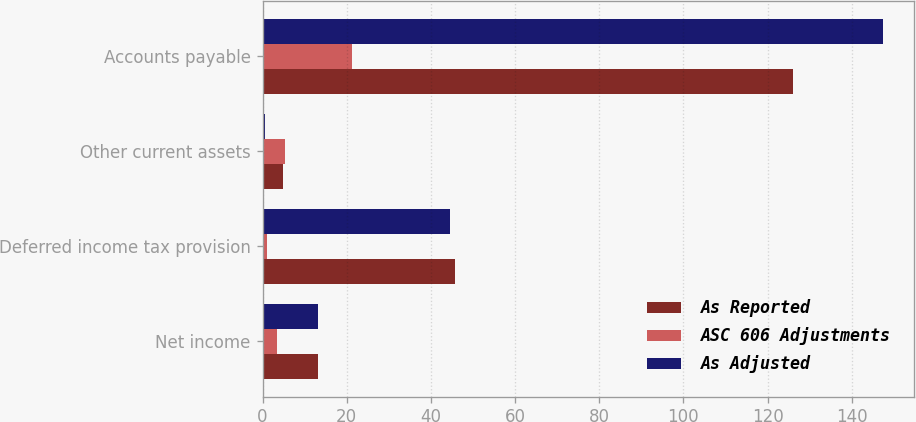Convert chart to OTSL. <chart><loc_0><loc_0><loc_500><loc_500><stacked_bar_chart><ecel><fcel>Net income<fcel>Deferred income tax provision<fcel>Other current assets<fcel>Accounts payable<nl><fcel>As Reported<fcel>13.3<fcel>45.7<fcel>4.8<fcel>126.1<nl><fcel>ASC 606 Adjustments<fcel>3.5<fcel>1.1<fcel>5.3<fcel>21.3<nl><fcel>As Adjusted<fcel>13.3<fcel>44.6<fcel>0.5<fcel>147.4<nl></chart> 